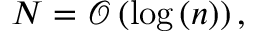Convert formula to latex. <formula><loc_0><loc_0><loc_500><loc_500>N = \mathcal { O } \left ( \log \left ( n \right ) \right ) ,</formula> 